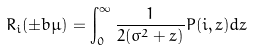Convert formula to latex. <formula><loc_0><loc_0><loc_500><loc_500>R _ { i } ( \pm b \mu ) = \int _ { 0 } ^ { \infty } \frac { 1 } { 2 ( \sigma ^ { 2 } + z ) } P ( i , z ) d z</formula> 